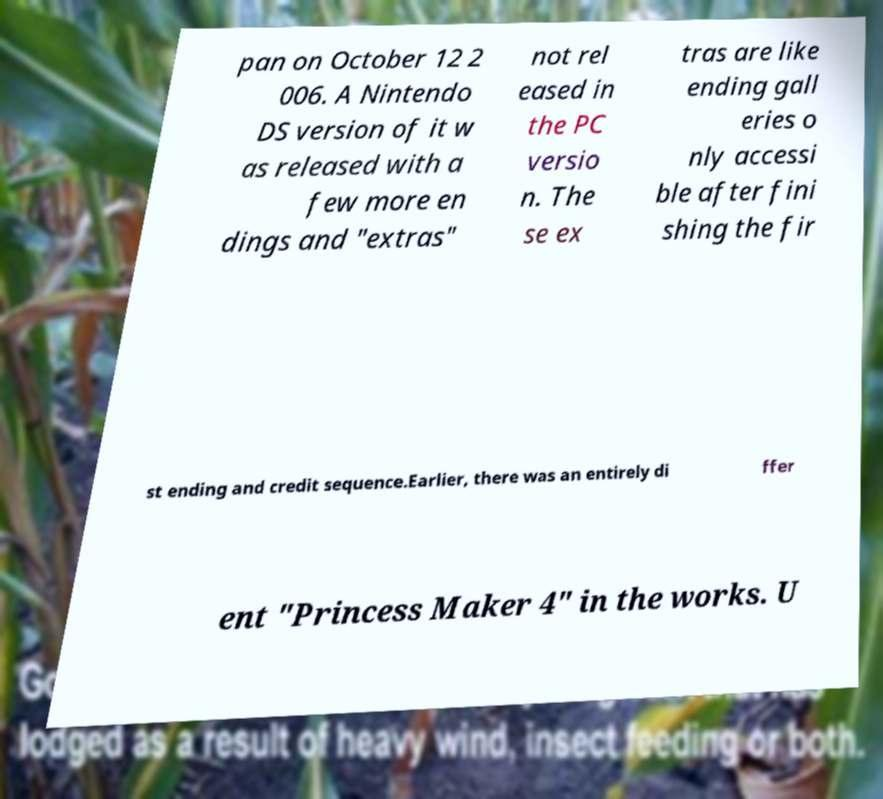Please identify and transcribe the text found in this image. pan on October 12 2 006. A Nintendo DS version of it w as released with a few more en dings and "extras" not rel eased in the PC versio n. The se ex tras are like ending gall eries o nly accessi ble after fini shing the fir st ending and credit sequence.Earlier, there was an entirely di ffer ent "Princess Maker 4" in the works. U 